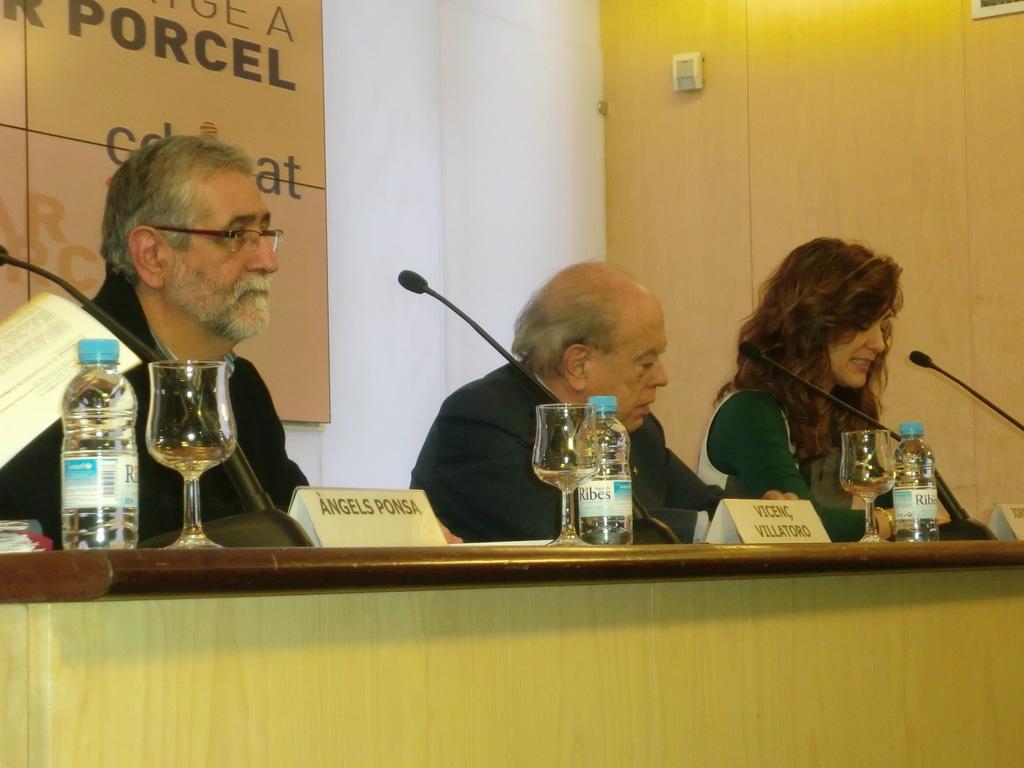What is written above the man's head on the wall?
Provide a short and direct response. Porcel. 